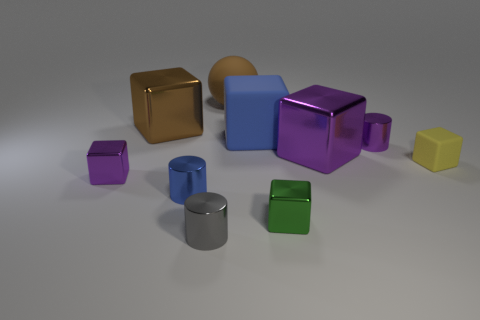Subtract all gray metal cylinders. How many cylinders are left? 2 Subtract all cylinders. How many objects are left? 7 Subtract 2 blocks. How many blocks are left? 4 Add 1 tiny rubber spheres. How many tiny rubber spheres exist? 1 Subtract all green cubes. How many cubes are left? 5 Subtract 0 brown cylinders. How many objects are left? 10 Subtract all gray cylinders. Subtract all gray blocks. How many cylinders are left? 2 Subtract all yellow balls. How many cyan cylinders are left? 0 Subtract all gray metal cylinders. Subtract all large blue matte blocks. How many objects are left? 8 Add 2 green objects. How many green objects are left? 3 